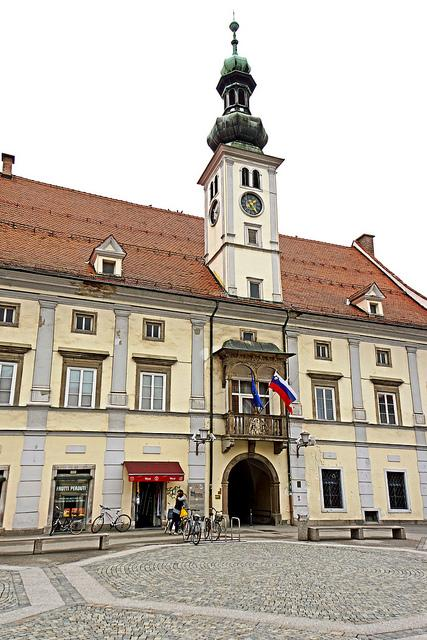What is under the clock tower? Please explain your reasoning. flags. There are tarps representing countries. 